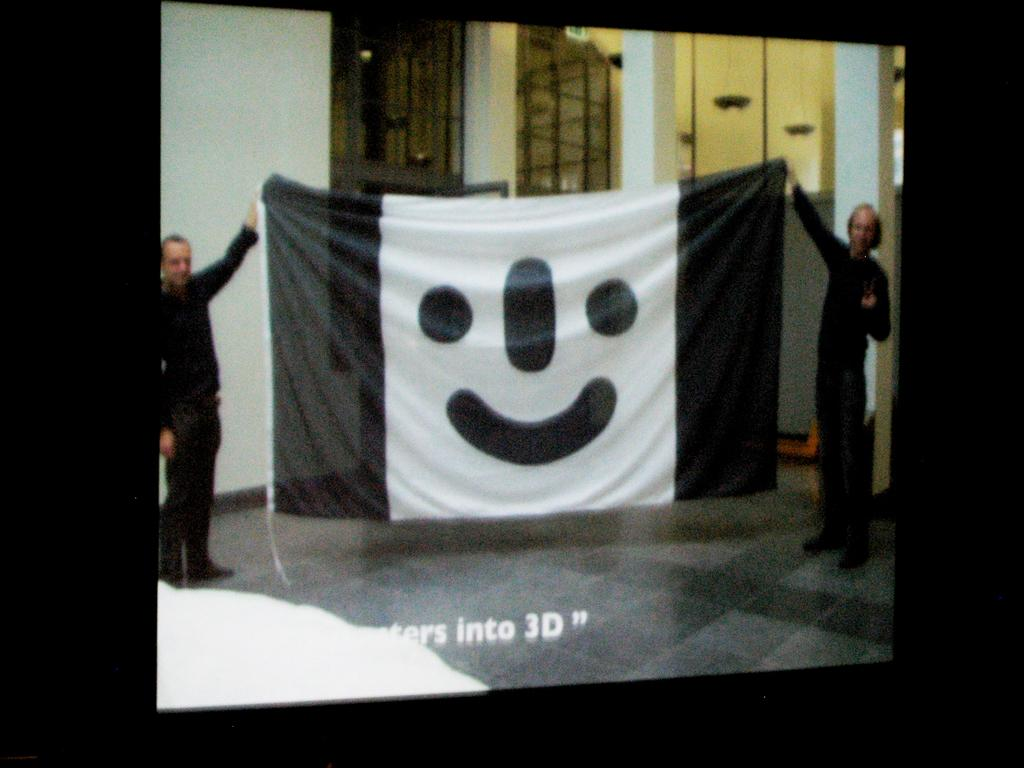How many people are in the image? There are two persons in the image. What are the persons holding in the image? The persons are holding a poster. What can be seen in the background of the image? There are pillars visible in the background of the image. What type of rake is being used by the persons in the image? There is no rake present in the image; the persons are holding a poster. How often does the image change during the week? The image does not change during the week; it is a static image. 